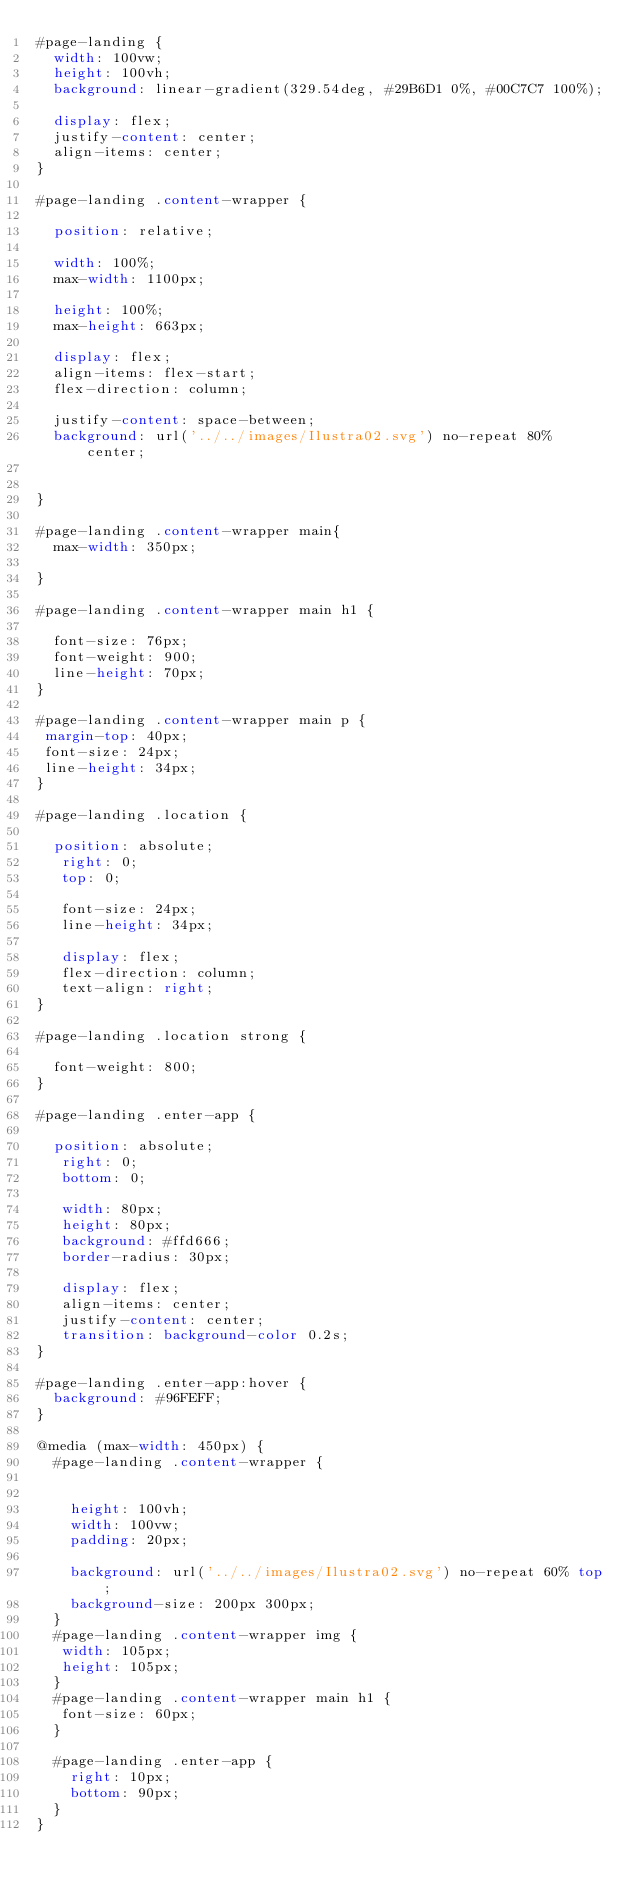Convert code to text. <code><loc_0><loc_0><loc_500><loc_500><_CSS_>#page-landing {
  width: 100vw;
  height: 100vh;
  background: linear-gradient(329.54deg, #29B6D1 0%, #00C7C7 100%);

  display: flex;
  justify-content: center;
  align-items: center;
}

#page-landing .content-wrapper {

  position: relative;
  
  width: 100%;
  max-width: 1100px;

  height: 100%;
  max-height: 663px;

  display: flex;
  align-items: flex-start;
  flex-direction: column;

  justify-content: space-between;
  background: url('../../images/Ilustra02.svg') no-repeat 80% center;

  
}

#page-landing .content-wrapper main{
  max-width: 350px;

}

#page-landing .content-wrapper main h1 {

  font-size: 76px;
  font-weight: 900;
  line-height: 70px;
}

#page-landing .content-wrapper main p {
 margin-top: 40px;
 font-size: 24px;
 line-height: 34px;
}

#page-landing .location {

  position: absolute;
   right: 0;
   top: 0;

   font-size: 24px;
   line-height: 34px;

   display: flex;
   flex-direction: column;
   text-align: right;
}

#page-landing .location strong {

  font-weight: 800;
}

#page-landing .enter-app {

  position: absolute;
   right: 0;
   bottom: 0;

   width: 80px;
   height: 80px;
   background: #ffd666;
   border-radius: 30px;

   display: flex;
   align-items: center;
   justify-content: center;
   transition: background-color 0.2s;
}

#page-landing .enter-app:hover {
  background: #96FEFF;
}

@media (max-width: 450px) {
  #page-landing .content-wrapper {
 

    height: 100vh;
    width: 100vw;
    padding: 20px;

    background: url('../../images/Ilustra02.svg') no-repeat 60% top;
    background-size: 200px 300px;
  }
  #page-landing .content-wrapper img {
   width: 105px;
   height: 105px;
  }
  #page-landing .content-wrapper main h1 {
   font-size: 60px;
  }

  #page-landing .enter-app {
    right: 10px;
    bottom: 90px;
  }
}</code> 